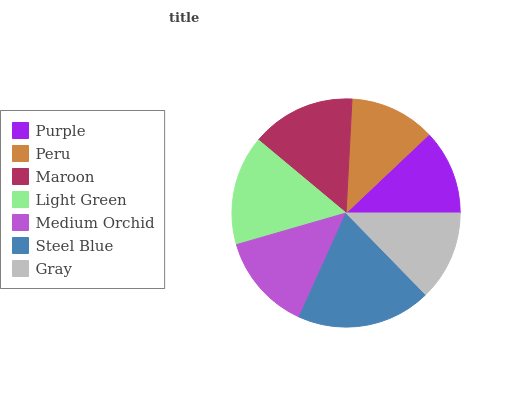Is Purple the minimum?
Answer yes or no. Yes. Is Steel Blue the maximum?
Answer yes or no. Yes. Is Peru the minimum?
Answer yes or no. No. Is Peru the maximum?
Answer yes or no. No. Is Peru greater than Purple?
Answer yes or no. Yes. Is Purple less than Peru?
Answer yes or no. Yes. Is Purple greater than Peru?
Answer yes or no. No. Is Peru less than Purple?
Answer yes or no. No. Is Medium Orchid the high median?
Answer yes or no. Yes. Is Medium Orchid the low median?
Answer yes or no. Yes. Is Peru the high median?
Answer yes or no. No. Is Peru the low median?
Answer yes or no. No. 